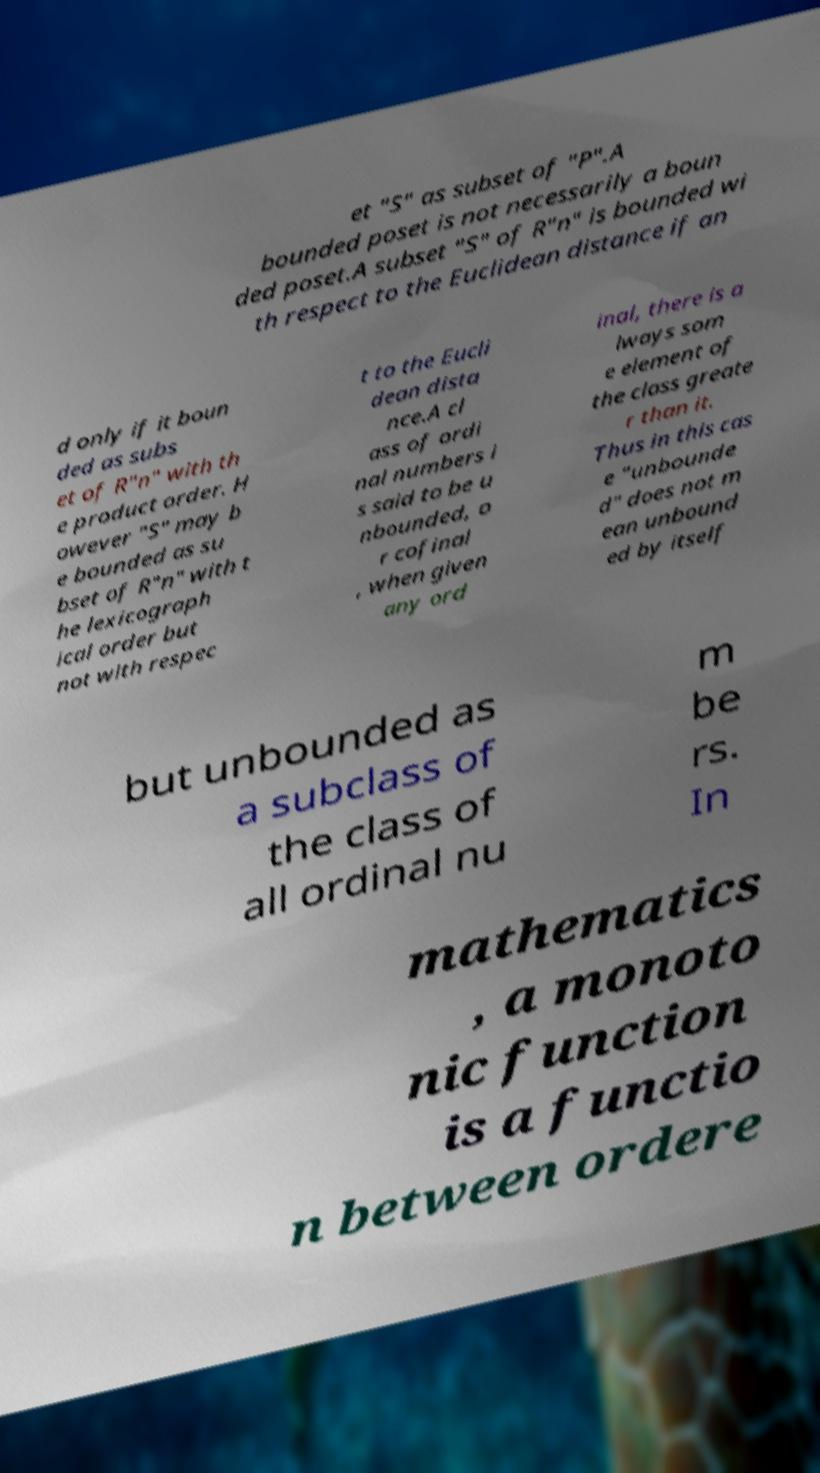Can you accurately transcribe the text from the provided image for me? et "S" as subset of "P".A bounded poset is not necessarily a boun ded poset.A subset "S" of R"n" is bounded wi th respect to the Euclidean distance if an d only if it boun ded as subs et of R"n" with th e product order. H owever "S" may b e bounded as su bset of R"n" with t he lexicograph ical order but not with respec t to the Eucli dean dista nce.A cl ass of ordi nal numbers i s said to be u nbounded, o r cofinal , when given any ord inal, there is a lways som e element of the class greate r than it. Thus in this cas e "unbounde d" does not m ean unbound ed by itself but unbounded as a subclass of the class of all ordinal nu m be rs. In mathematics , a monoto nic function is a functio n between ordere 